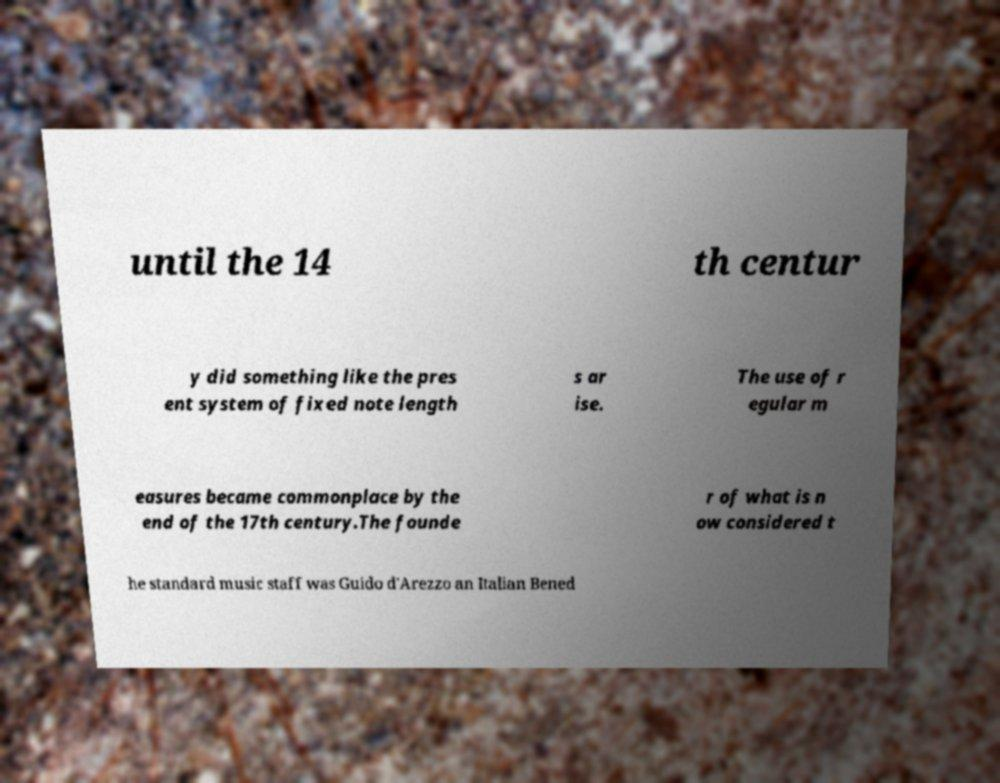There's text embedded in this image that I need extracted. Can you transcribe it verbatim? until the 14 th centur y did something like the pres ent system of fixed note length s ar ise. The use of r egular m easures became commonplace by the end of the 17th century.The founde r of what is n ow considered t he standard music staff was Guido d'Arezzo an Italian Bened 